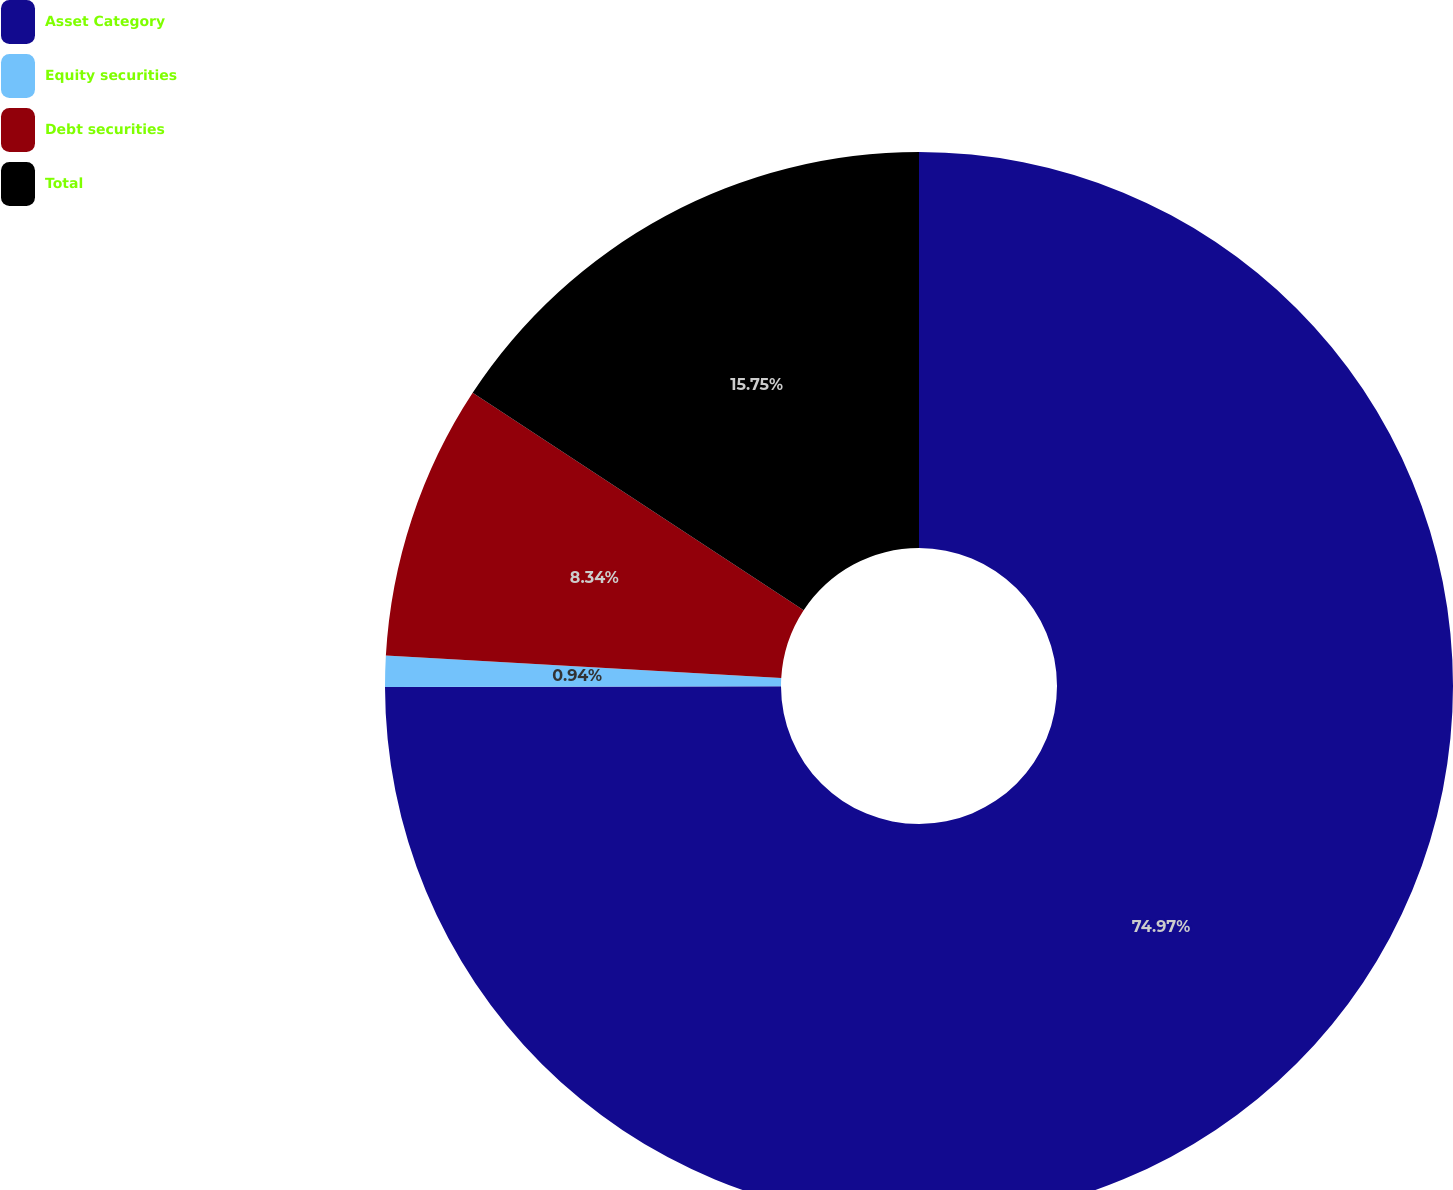<chart> <loc_0><loc_0><loc_500><loc_500><pie_chart><fcel>Asset Category<fcel>Equity securities<fcel>Debt securities<fcel>Total<nl><fcel>74.97%<fcel>0.94%<fcel>8.34%<fcel>15.75%<nl></chart> 